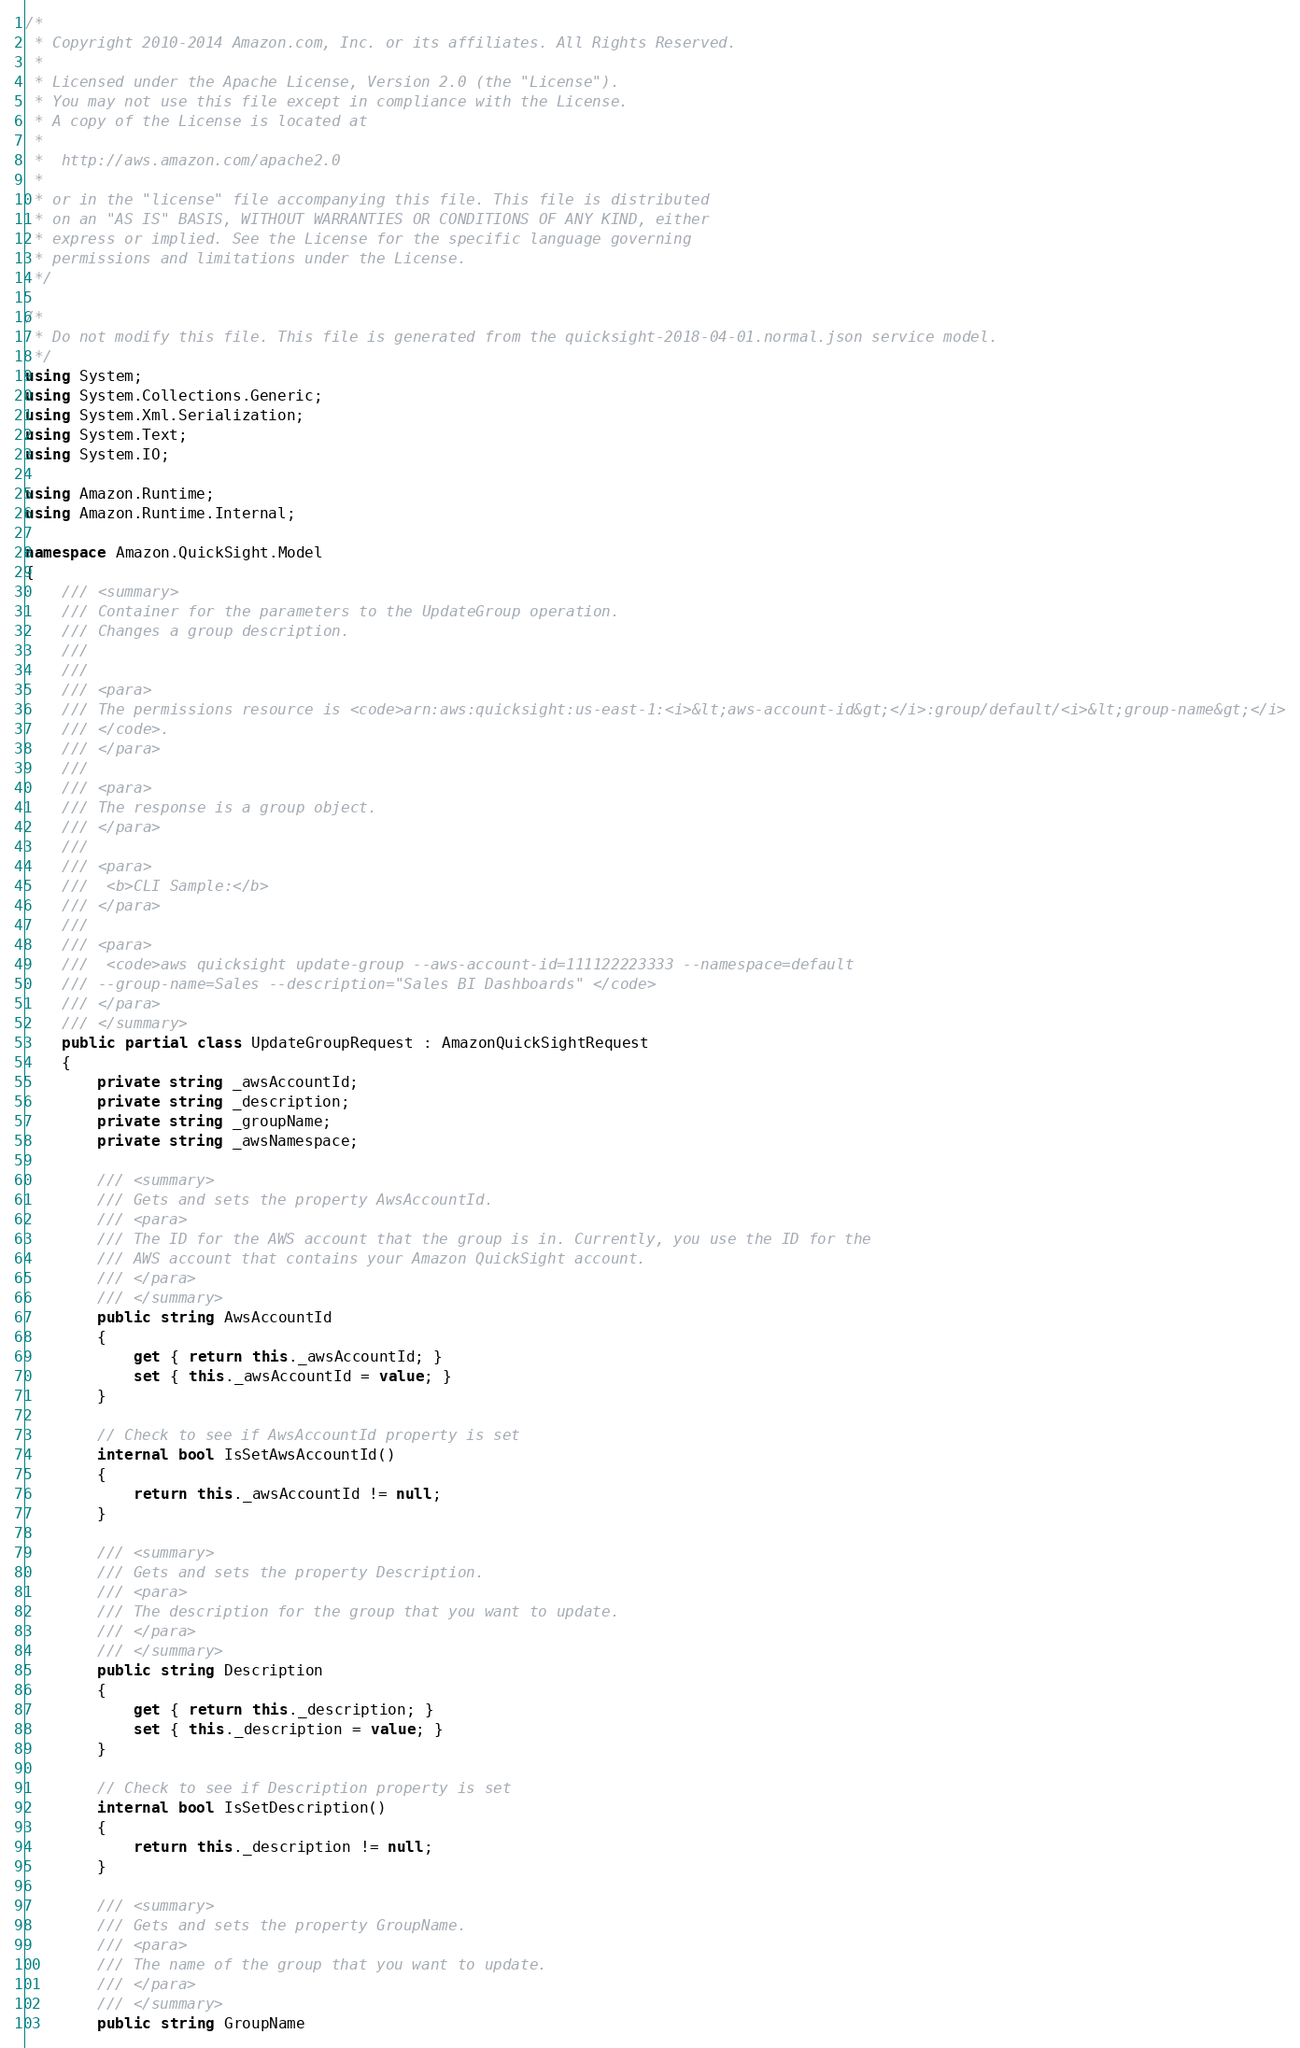Convert code to text. <code><loc_0><loc_0><loc_500><loc_500><_C#_>/*
 * Copyright 2010-2014 Amazon.com, Inc. or its affiliates. All Rights Reserved.
 * 
 * Licensed under the Apache License, Version 2.0 (the "License").
 * You may not use this file except in compliance with the License.
 * A copy of the License is located at
 * 
 *  http://aws.amazon.com/apache2.0
 * 
 * or in the "license" file accompanying this file. This file is distributed
 * on an "AS IS" BASIS, WITHOUT WARRANTIES OR CONDITIONS OF ANY KIND, either
 * express or implied. See the License for the specific language governing
 * permissions and limitations under the License.
 */

/*
 * Do not modify this file. This file is generated from the quicksight-2018-04-01.normal.json service model.
 */
using System;
using System.Collections.Generic;
using System.Xml.Serialization;
using System.Text;
using System.IO;

using Amazon.Runtime;
using Amazon.Runtime.Internal;

namespace Amazon.QuickSight.Model
{
    /// <summary>
    /// Container for the parameters to the UpdateGroup operation.
    /// Changes a group description. 
    /// 
    ///  
    /// <para>
    /// The permissions resource is <code>arn:aws:quicksight:us-east-1:<i>&lt;aws-account-id&gt;</i>:group/default/<i>&lt;group-name&gt;</i>
    /// </code>.
    /// </para>
    ///  
    /// <para>
    /// The response is a group object.
    /// </para>
    ///  
    /// <para>
    ///  <b>CLI Sample:</b> 
    /// </para>
    ///  
    /// <para>
    ///  <code>aws quicksight update-group --aws-account-id=111122223333 --namespace=default
    /// --group-name=Sales --description="Sales BI Dashboards" </code> 
    /// </para>
    /// </summary>
    public partial class UpdateGroupRequest : AmazonQuickSightRequest
    {
        private string _awsAccountId;
        private string _description;
        private string _groupName;
        private string _awsNamespace;

        /// <summary>
        /// Gets and sets the property AwsAccountId. 
        /// <para>
        /// The ID for the AWS account that the group is in. Currently, you use the ID for the
        /// AWS account that contains your Amazon QuickSight account.
        /// </para>
        /// </summary>
        public string AwsAccountId
        {
            get { return this._awsAccountId; }
            set { this._awsAccountId = value; }
        }

        // Check to see if AwsAccountId property is set
        internal bool IsSetAwsAccountId()
        {
            return this._awsAccountId != null;
        }

        /// <summary>
        /// Gets and sets the property Description. 
        /// <para>
        /// The description for the group that you want to update.
        /// </para>
        /// </summary>
        public string Description
        {
            get { return this._description; }
            set { this._description = value; }
        }

        // Check to see if Description property is set
        internal bool IsSetDescription()
        {
            return this._description != null;
        }

        /// <summary>
        /// Gets and sets the property GroupName. 
        /// <para>
        /// The name of the group that you want to update.
        /// </para>
        /// </summary>
        public string GroupName</code> 